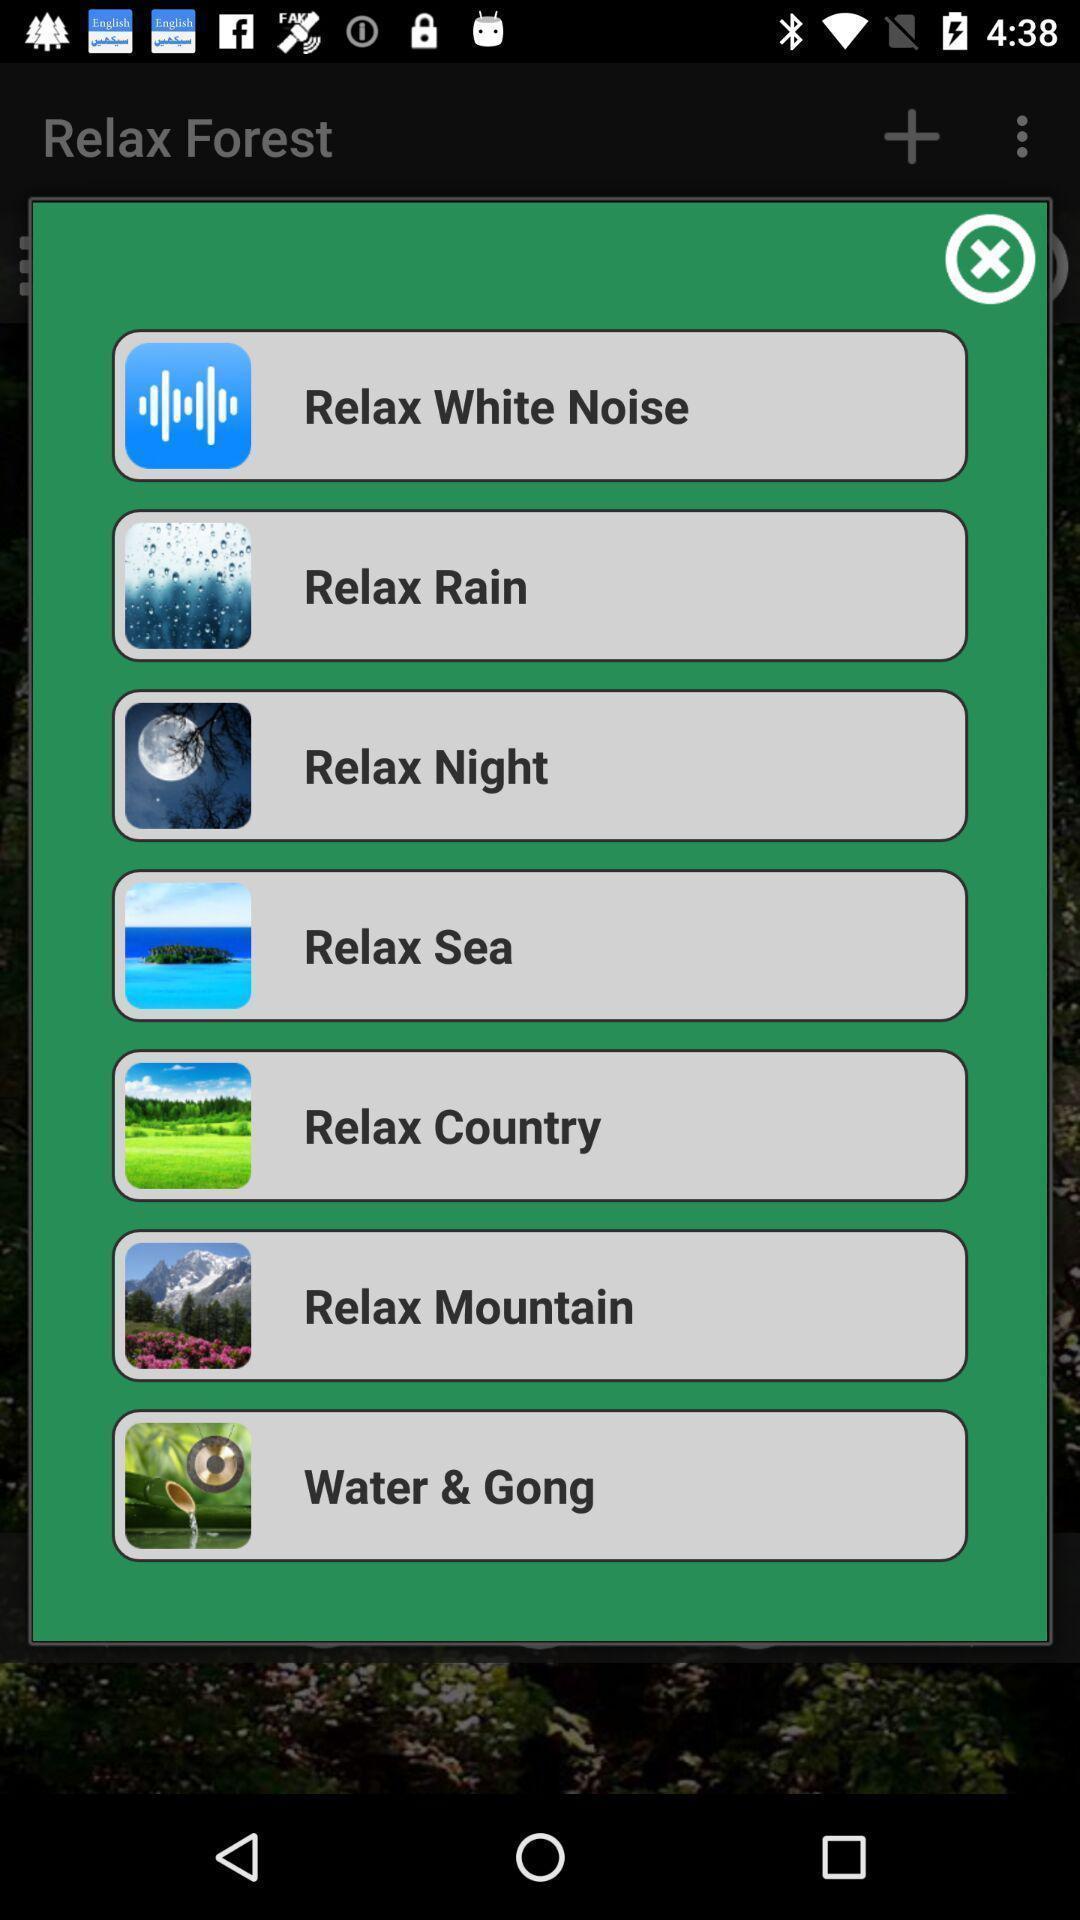Provide a textual representation of this image. Pop-up displaying different categories available. 